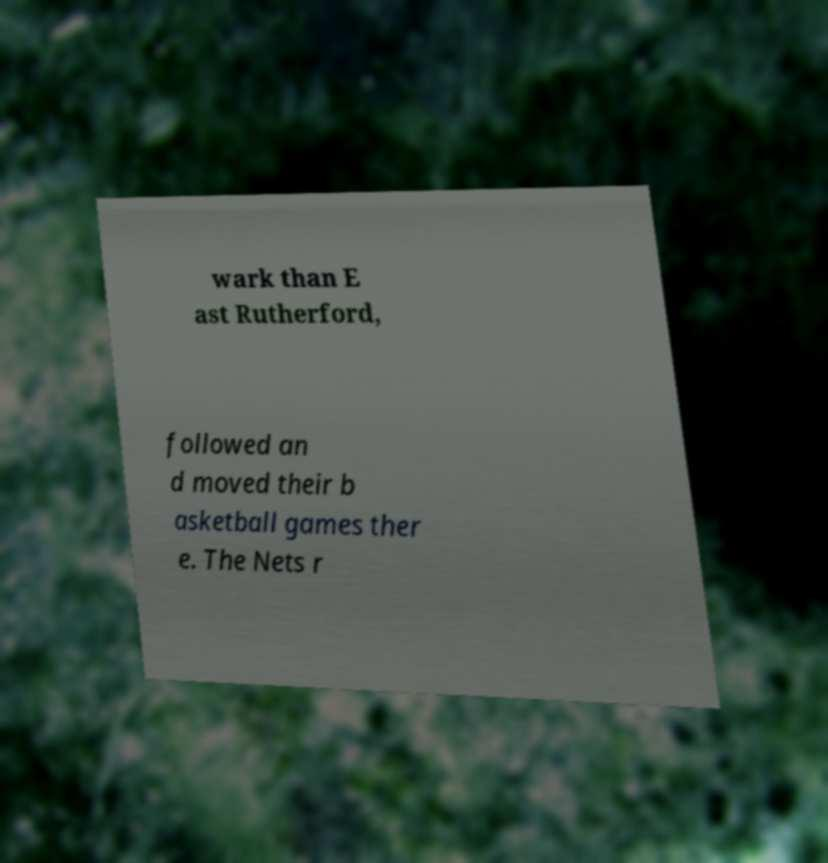Please read and relay the text visible in this image. What does it say? wark than E ast Rutherford, followed an d moved their b asketball games ther e. The Nets r 